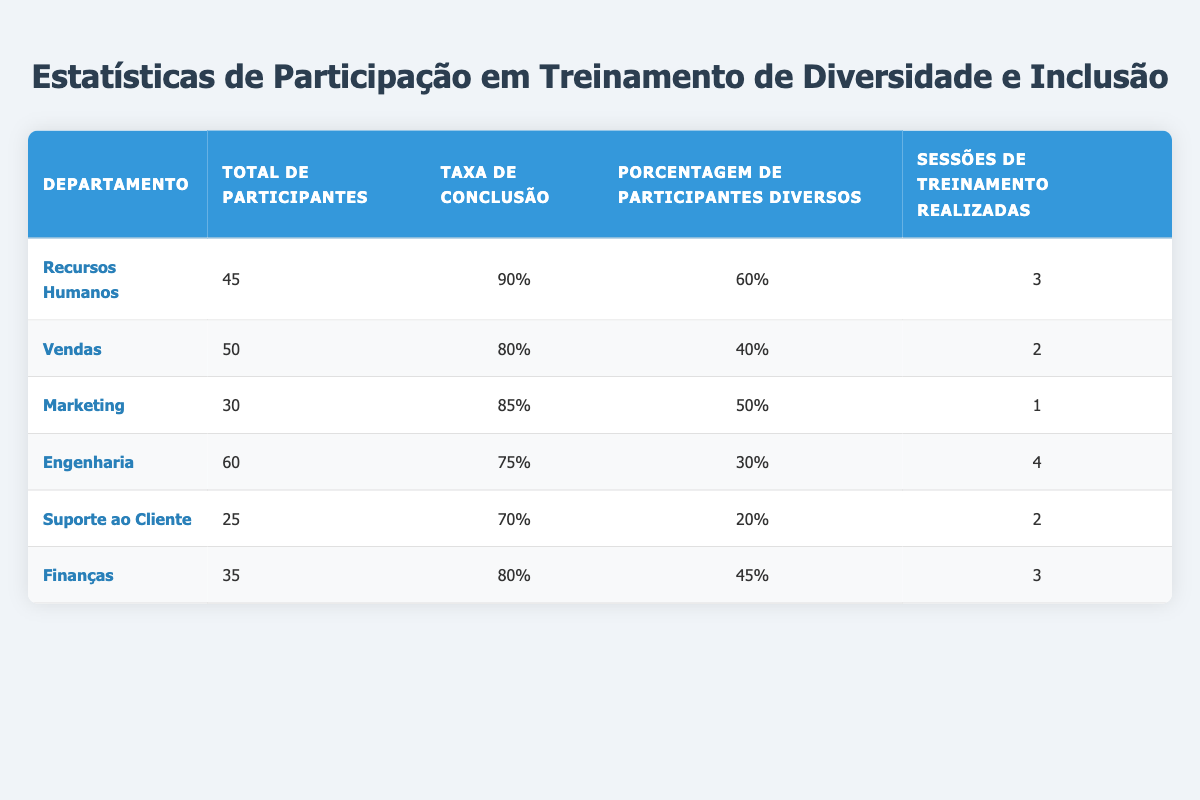Qual departamento teve a maior taxa de conclusão? O departamento de Recursos Humanos teve a maior taxa de conclusão com 90%. Isso é verificado ao observar a coluna "Taxa de Conclusão" e encontrar que o valor 90 é o mais alto.
Answer: Recursos Humanos Qual é a porcentagem de participantes diversos no departamento de Suporte ao Cliente? A porcentagem de participantes diversos no departamento de Suporte ao Cliente é 20%. Essa informação pode ser encontrada na coluna "Porcentagem de Participantes Diversos" correspondente a esse departamento.
Answer: 20 Qual é a média da taxa de conclusão entre todos os departamentos? Para calcular a média, somamos todas as taxas de conclusão: 90 + 80 + 85 + 75 + 70 + 80 = 480. Em seguida, dividimos pelo número de departamentos, que é 6, resultando em 480/6 = 80.
Answer: 80 O departamento de Engenharia teve uma taxa de conclusão maior que 80%? Não, a taxa de conclusão do departamento de Engenharia é 75%, o que é inferior a 80%. Essa informação está disponível na coluna "Taxa de Conclusão" para Engenharia.
Answer: Não Qual departamento tem a maior quantidade de participantes diversos? O departamento de Recursos Humanos possui a maior quantidade de participantes diversos com 60%. Para isso, observamos a coluna "Porcentagem de Participantes Diversos" e comparamos os valores.
Answer: 60 Quantas sessões de treinamento foram conduzidas no departamento de Marketing? O departamento de Marketing teve 1 sessão de treinamento conduzida. Esta informação é facilmente acessível na coluna "Sessões de Treinamento Realizadas" para Marketing.
Answer: 1 Qual é a soma total de participantes de todos os departamentos? Para encontrar a soma total, somamos todos os participantes: 45 + 50 + 30 + 60 + 25 + 35 = 245. Portanto, a soma total de participantes é 245.
Answer: 245 Mais de 50% dos participantes no departamento de Vendas eram diversos? Não, somente 40% dos participantes no departamento de Vendas eram diversos. Essa informação foi verificada na coluna "Porcentagem de Participantes Diversos" para Vendas.
Answer: Não 